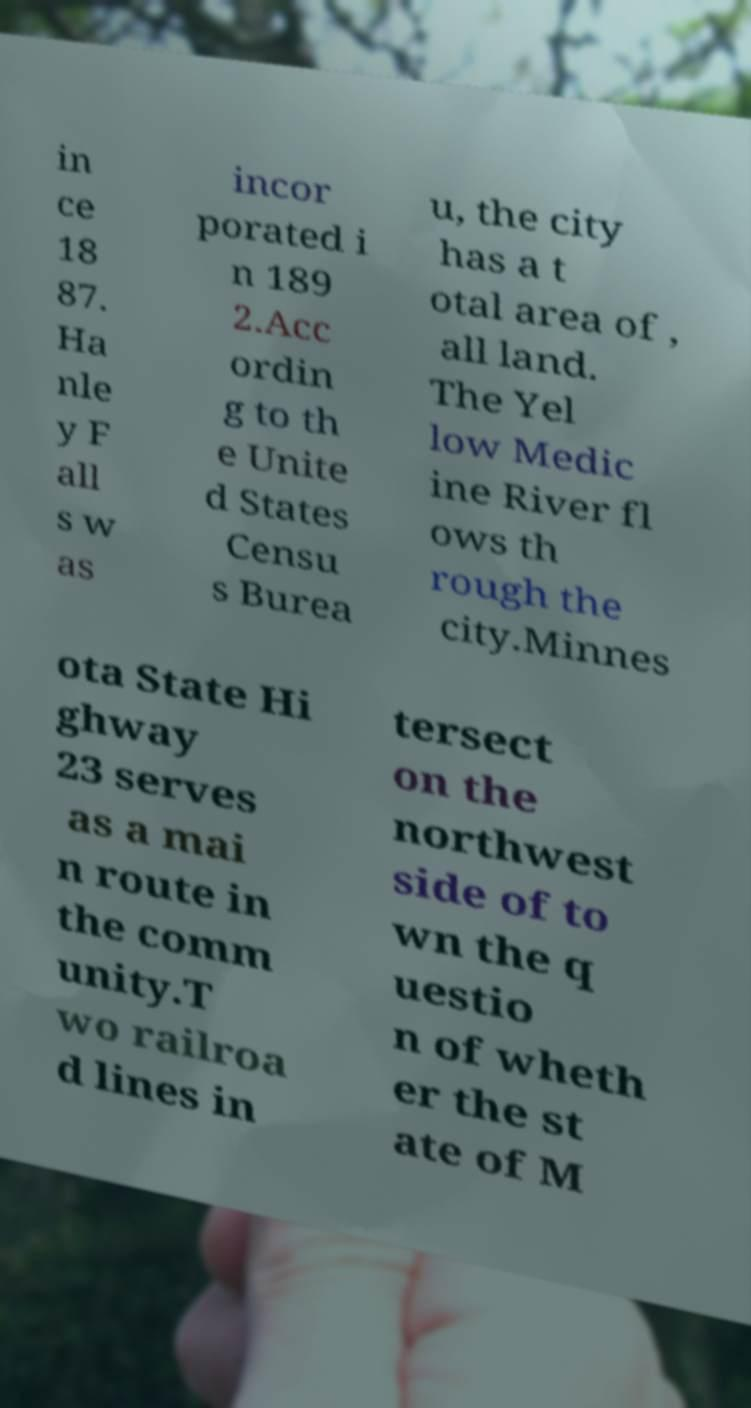Could you assist in decoding the text presented in this image and type it out clearly? in ce 18 87. Ha nle y F all s w as incor porated i n 189 2.Acc ordin g to th e Unite d States Censu s Burea u, the city has a t otal area of , all land. The Yel low Medic ine River fl ows th rough the city.Minnes ota State Hi ghway 23 serves as a mai n route in the comm unity.T wo railroa d lines in tersect on the northwest side of to wn the q uestio n of wheth er the st ate of M 